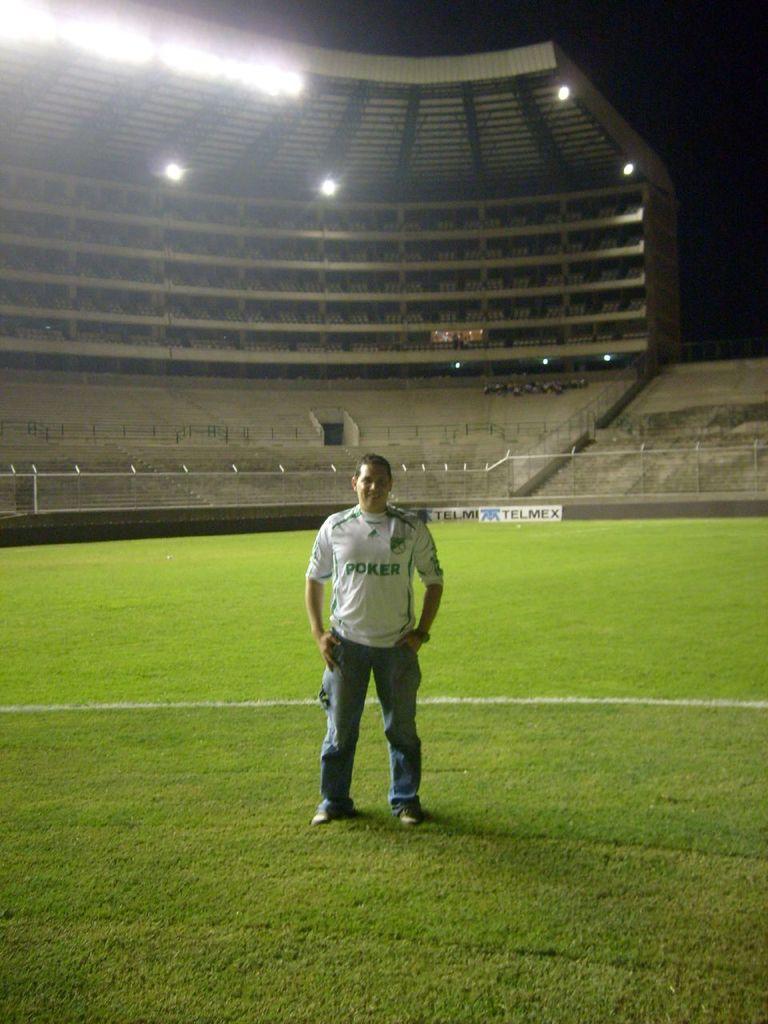How many people are standing in the field?
Your response must be concise. Answering does not require reading text in the image. 